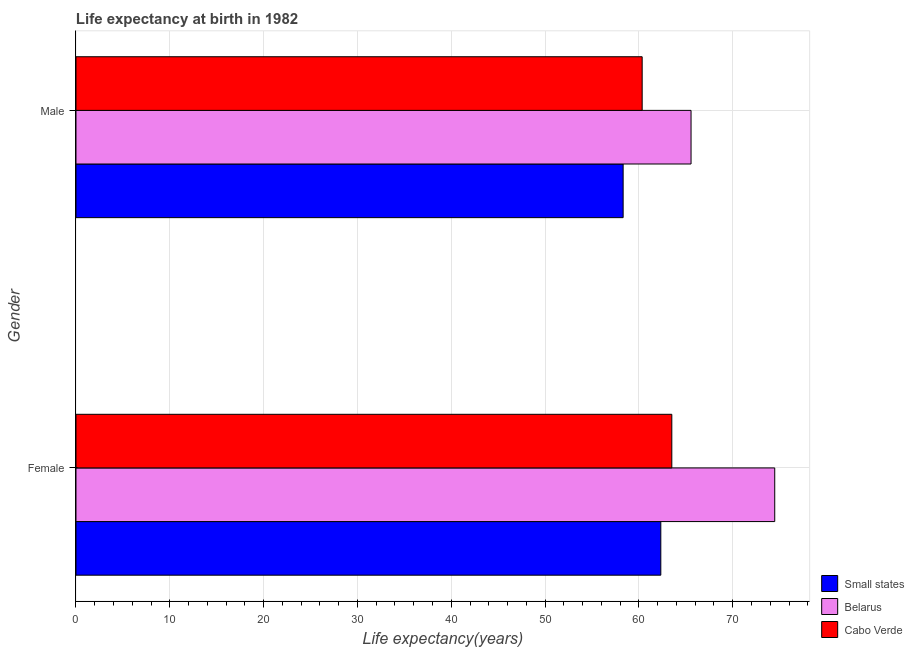How many different coloured bars are there?
Your response must be concise. 3. Are the number of bars per tick equal to the number of legend labels?
Your response must be concise. Yes. How many bars are there on the 1st tick from the top?
Your answer should be compact. 3. How many bars are there on the 1st tick from the bottom?
Your response must be concise. 3. What is the life expectancy(male) in Cabo Verde?
Ensure brevity in your answer.  60.35. Across all countries, what is the maximum life expectancy(male)?
Ensure brevity in your answer.  65.56. Across all countries, what is the minimum life expectancy(female)?
Your answer should be very brief. 62.34. In which country was the life expectancy(male) maximum?
Offer a terse response. Belarus. In which country was the life expectancy(female) minimum?
Your response must be concise. Small states. What is the total life expectancy(female) in the graph?
Your answer should be very brief. 200.32. What is the difference between the life expectancy(female) in Cabo Verde and that in Belarus?
Give a very brief answer. -10.97. What is the difference between the life expectancy(female) in Small states and the life expectancy(male) in Cabo Verde?
Keep it short and to the point. 1.99. What is the average life expectancy(female) per country?
Provide a short and direct response. 66.77. What is the difference between the life expectancy(male) and life expectancy(female) in Cabo Verde?
Ensure brevity in your answer.  -3.16. In how many countries, is the life expectancy(female) greater than 46 years?
Make the answer very short. 3. What is the ratio of the life expectancy(male) in Belarus to that in Small states?
Ensure brevity in your answer.  1.12. In how many countries, is the life expectancy(male) greater than the average life expectancy(male) taken over all countries?
Ensure brevity in your answer.  1. What does the 2nd bar from the top in Female represents?
Make the answer very short. Belarus. What does the 1st bar from the bottom in Female represents?
Keep it short and to the point. Small states. How many bars are there?
Your answer should be compact. 6. Are all the bars in the graph horizontal?
Provide a short and direct response. Yes. How many countries are there in the graph?
Keep it short and to the point. 3. What is the difference between two consecutive major ticks on the X-axis?
Provide a succinct answer. 10. Does the graph contain any zero values?
Offer a very short reply. No. Does the graph contain grids?
Keep it short and to the point. Yes. Where does the legend appear in the graph?
Offer a terse response. Bottom right. How are the legend labels stacked?
Provide a succinct answer. Vertical. What is the title of the graph?
Provide a succinct answer. Life expectancy at birth in 1982. Does "Turkmenistan" appear as one of the legend labels in the graph?
Give a very brief answer. No. What is the label or title of the X-axis?
Provide a short and direct response. Life expectancy(years). What is the Life expectancy(years) of Small states in Female?
Keep it short and to the point. 62.34. What is the Life expectancy(years) of Belarus in Female?
Provide a succinct answer. 74.48. What is the Life expectancy(years) in Cabo Verde in Female?
Offer a terse response. 63.51. What is the Life expectancy(years) in Small states in Male?
Your response must be concise. 58.32. What is the Life expectancy(years) of Belarus in Male?
Provide a short and direct response. 65.56. What is the Life expectancy(years) in Cabo Verde in Male?
Ensure brevity in your answer.  60.35. Across all Gender, what is the maximum Life expectancy(years) in Small states?
Ensure brevity in your answer.  62.34. Across all Gender, what is the maximum Life expectancy(years) of Belarus?
Offer a terse response. 74.48. Across all Gender, what is the maximum Life expectancy(years) in Cabo Verde?
Make the answer very short. 63.51. Across all Gender, what is the minimum Life expectancy(years) of Small states?
Make the answer very short. 58.32. Across all Gender, what is the minimum Life expectancy(years) of Belarus?
Offer a very short reply. 65.56. Across all Gender, what is the minimum Life expectancy(years) of Cabo Verde?
Offer a terse response. 60.35. What is the total Life expectancy(years) of Small states in the graph?
Make the answer very short. 120.66. What is the total Life expectancy(years) of Belarus in the graph?
Your answer should be very brief. 140.03. What is the total Life expectancy(years) in Cabo Verde in the graph?
Your answer should be compact. 123.86. What is the difference between the Life expectancy(years) in Small states in Female and that in Male?
Ensure brevity in your answer.  4.02. What is the difference between the Life expectancy(years) of Belarus in Female and that in Male?
Make the answer very short. 8.92. What is the difference between the Life expectancy(years) in Cabo Verde in Female and that in Male?
Provide a short and direct response. 3.16. What is the difference between the Life expectancy(years) of Small states in Female and the Life expectancy(years) of Belarus in Male?
Your response must be concise. -3.22. What is the difference between the Life expectancy(years) of Small states in Female and the Life expectancy(years) of Cabo Verde in Male?
Your answer should be very brief. 1.99. What is the difference between the Life expectancy(years) in Belarus in Female and the Life expectancy(years) in Cabo Verde in Male?
Give a very brief answer. 14.13. What is the average Life expectancy(years) in Small states per Gender?
Your answer should be very brief. 60.33. What is the average Life expectancy(years) of Belarus per Gender?
Your answer should be very brief. 70.02. What is the average Life expectancy(years) in Cabo Verde per Gender?
Make the answer very short. 61.93. What is the difference between the Life expectancy(years) in Small states and Life expectancy(years) in Belarus in Female?
Your response must be concise. -12.14. What is the difference between the Life expectancy(years) in Small states and Life expectancy(years) in Cabo Verde in Female?
Offer a very short reply. -1.17. What is the difference between the Life expectancy(years) in Belarus and Life expectancy(years) in Cabo Verde in Female?
Keep it short and to the point. 10.97. What is the difference between the Life expectancy(years) in Small states and Life expectancy(years) in Belarus in Male?
Your response must be concise. -7.24. What is the difference between the Life expectancy(years) of Small states and Life expectancy(years) of Cabo Verde in Male?
Offer a terse response. -2.03. What is the difference between the Life expectancy(years) of Belarus and Life expectancy(years) of Cabo Verde in Male?
Ensure brevity in your answer.  5.21. What is the ratio of the Life expectancy(years) in Small states in Female to that in Male?
Offer a very short reply. 1.07. What is the ratio of the Life expectancy(years) of Belarus in Female to that in Male?
Offer a very short reply. 1.14. What is the ratio of the Life expectancy(years) of Cabo Verde in Female to that in Male?
Your answer should be compact. 1.05. What is the difference between the highest and the second highest Life expectancy(years) of Small states?
Give a very brief answer. 4.02. What is the difference between the highest and the second highest Life expectancy(years) of Belarus?
Your response must be concise. 8.92. What is the difference between the highest and the second highest Life expectancy(years) of Cabo Verde?
Keep it short and to the point. 3.16. What is the difference between the highest and the lowest Life expectancy(years) of Small states?
Your response must be concise. 4.02. What is the difference between the highest and the lowest Life expectancy(years) in Belarus?
Give a very brief answer. 8.92. What is the difference between the highest and the lowest Life expectancy(years) of Cabo Verde?
Offer a terse response. 3.16. 